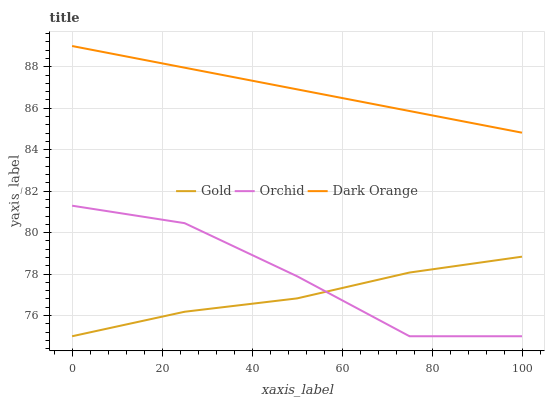Does Gold have the minimum area under the curve?
Answer yes or no. Yes. Does Dark Orange have the maximum area under the curve?
Answer yes or no. Yes. Does Orchid have the minimum area under the curve?
Answer yes or no. No. Does Orchid have the maximum area under the curve?
Answer yes or no. No. Is Dark Orange the smoothest?
Answer yes or no. Yes. Is Orchid the roughest?
Answer yes or no. Yes. Is Gold the smoothest?
Answer yes or no. No. Is Gold the roughest?
Answer yes or no. No. Does Gold have the lowest value?
Answer yes or no. Yes. Does Dark Orange have the highest value?
Answer yes or no. Yes. Does Orchid have the highest value?
Answer yes or no. No. Is Orchid less than Dark Orange?
Answer yes or no. Yes. Is Dark Orange greater than Gold?
Answer yes or no. Yes. Does Gold intersect Orchid?
Answer yes or no. Yes. Is Gold less than Orchid?
Answer yes or no. No. Is Gold greater than Orchid?
Answer yes or no. No. Does Orchid intersect Dark Orange?
Answer yes or no. No. 